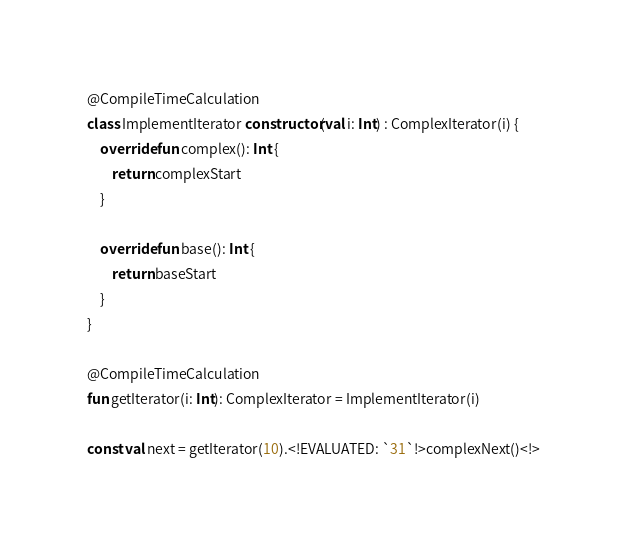<code> <loc_0><loc_0><loc_500><loc_500><_Kotlin_>@CompileTimeCalculation
class ImplementIterator constructor(val i: Int) : ComplexIterator(i) {
    override fun complex(): Int {
        return complexStart
    }

    override fun base(): Int {
        return baseStart
    }
}

@CompileTimeCalculation
fun getIterator(i: Int): ComplexIterator = ImplementIterator(i)

const val next = getIterator(10).<!EVALUATED: `31`!>complexNext()<!>
</code> 